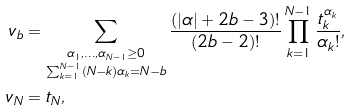<formula> <loc_0><loc_0><loc_500><loc_500>v _ { b } & = \sum _ { \substack { \alpha _ { 1 } , \dots , \alpha _ { N - 1 } \geq 0 \\ \sum _ { k = 1 } ^ { N - 1 } ( N - k ) \alpha _ { k } = N - b } } \frac { ( | \alpha | + 2 b - 3 ) ! } { ( 2 b - 2 ) ! } \prod _ { k = 1 } ^ { N - 1 } \frac { t _ { k } ^ { \alpha _ { k } } } { \alpha _ { k } ! } , \\ v _ { N } & = t _ { N } ,</formula> 